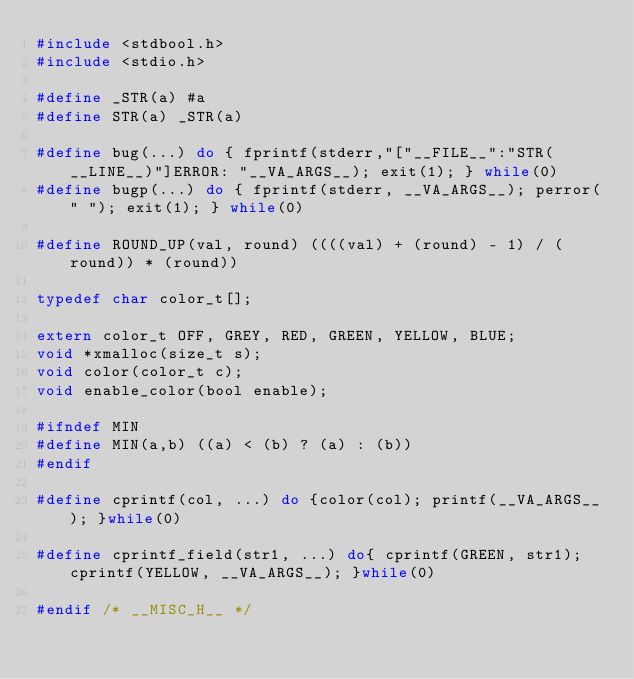Convert code to text. <code><loc_0><loc_0><loc_500><loc_500><_C_>#include <stdbool.h>
#include <stdio.h>

#define _STR(a) #a
#define STR(a) _STR(a)

#define bug(...) do { fprintf(stderr,"["__FILE__":"STR(__LINE__)"]ERROR: "__VA_ARGS__); exit(1); } while(0)
#define bugp(...) do { fprintf(stderr, __VA_ARGS__); perror(" "); exit(1); } while(0)

#define ROUND_UP(val, round) ((((val) + (round) - 1) / (round)) * (round))

typedef char color_t[];

extern color_t OFF, GREY, RED, GREEN, YELLOW, BLUE;
void *xmalloc(size_t s);
void color(color_t c);
void enable_color(bool enable);

#ifndef MIN
#define MIN(a,b) ((a) < (b) ? (a) : (b))
#endif

#define cprintf(col, ...) do {color(col); printf(__VA_ARGS__); }while(0)

#define cprintf_field(str1, ...) do{ cprintf(GREEN, str1); cprintf(YELLOW, __VA_ARGS__); }while(0)

#endif /* __MISC_H__ */
</code> 